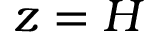Convert formula to latex. <formula><loc_0><loc_0><loc_500><loc_500>z = H</formula> 